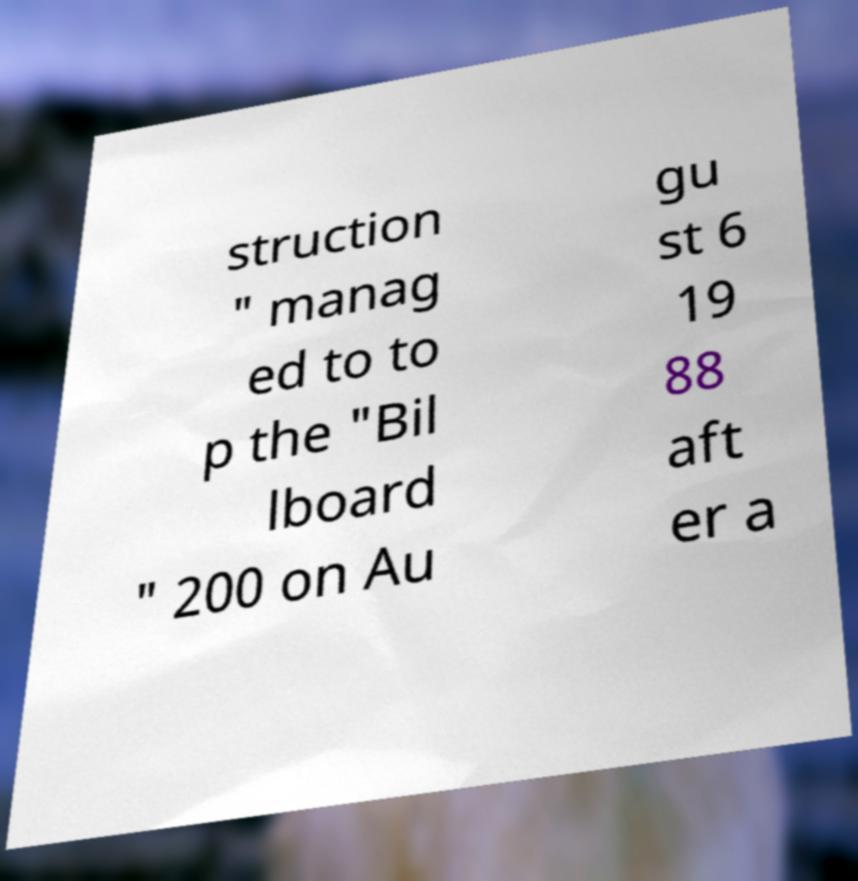Could you extract and type out the text from this image? struction " manag ed to to p the "Bil lboard " 200 on Au gu st 6 19 88 aft er a 